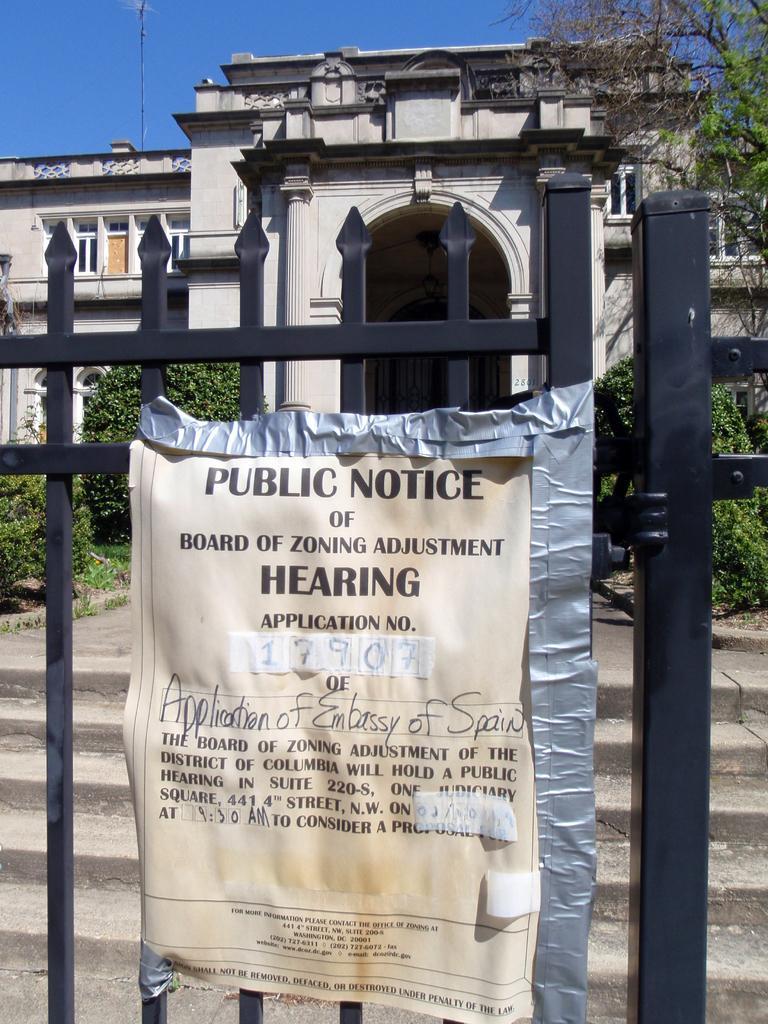Please provide a concise description of this image. In the image we can see a building. There are many plants and a tree in the image. There is a notice stuck on a gate. 